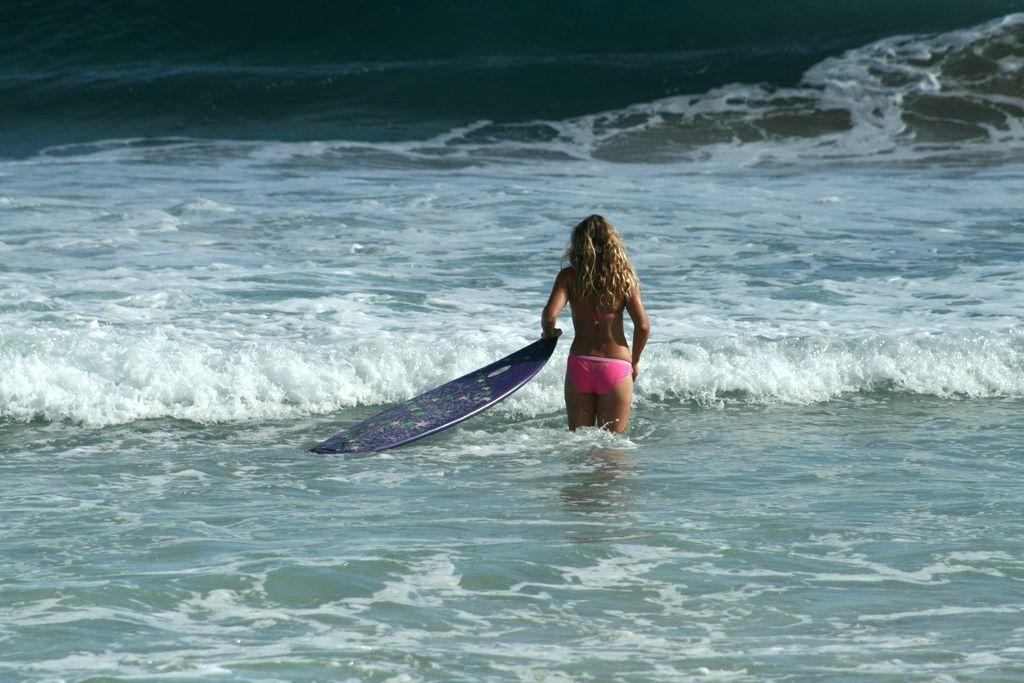Who is present in the image? There is a woman in the image. What is the woman holding in the image? The woman is holding a surfboard. Where is the woman located in the image? The woman is in the water. What type of worm can be seen crawling on the woman's suit in the image? There is no worm or suit present in the image; the woman is holding a surfboard and is in the water. 